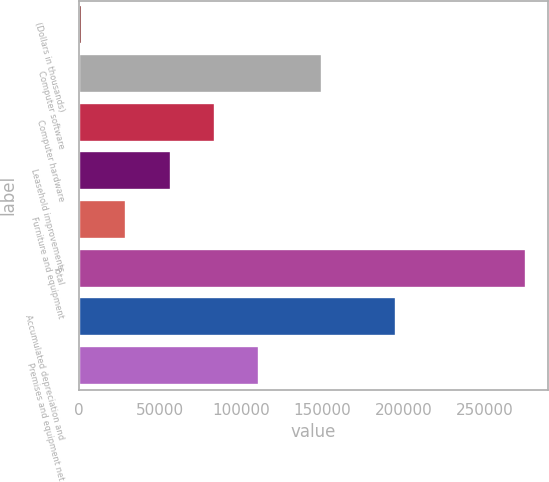Convert chart to OTSL. <chart><loc_0><loc_0><loc_500><loc_500><bar_chart><fcel>(Dollars in thousands)<fcel>Computer software<fcel>Computer hardware<fcel>Leasehold improvements<fcel>Furniture and equipment<fcel>Total<fcel>Accumulated depreciation and<fcel>Premises and equipment net<nl><fcel>2014<fcel>149579<fcel>83874.4<fcel>56587.6<fcel>29300.8<fcel>274882<fcel>195037<fcel>111161<nl></chart> 